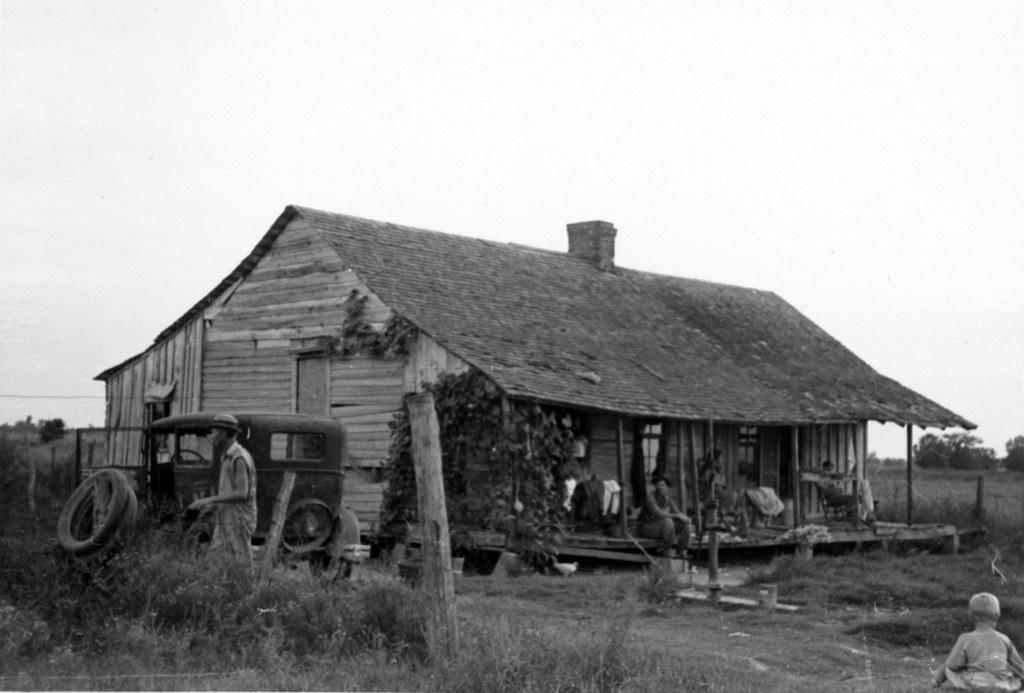What type of structure is present in the image? There is a house in the image. What can be seen on the land on the left side of the image? There is a vehicle on the land on the left side of the image. What type of vegetation is present on the left side of the image? There are plants on the left side of the image. What is visible in the background of the image? The sky is visible in the background of the image. What is the belief of the plants on the left side of the image? There is no indication of any beliefs in the image, as plants do not have beliefs. 